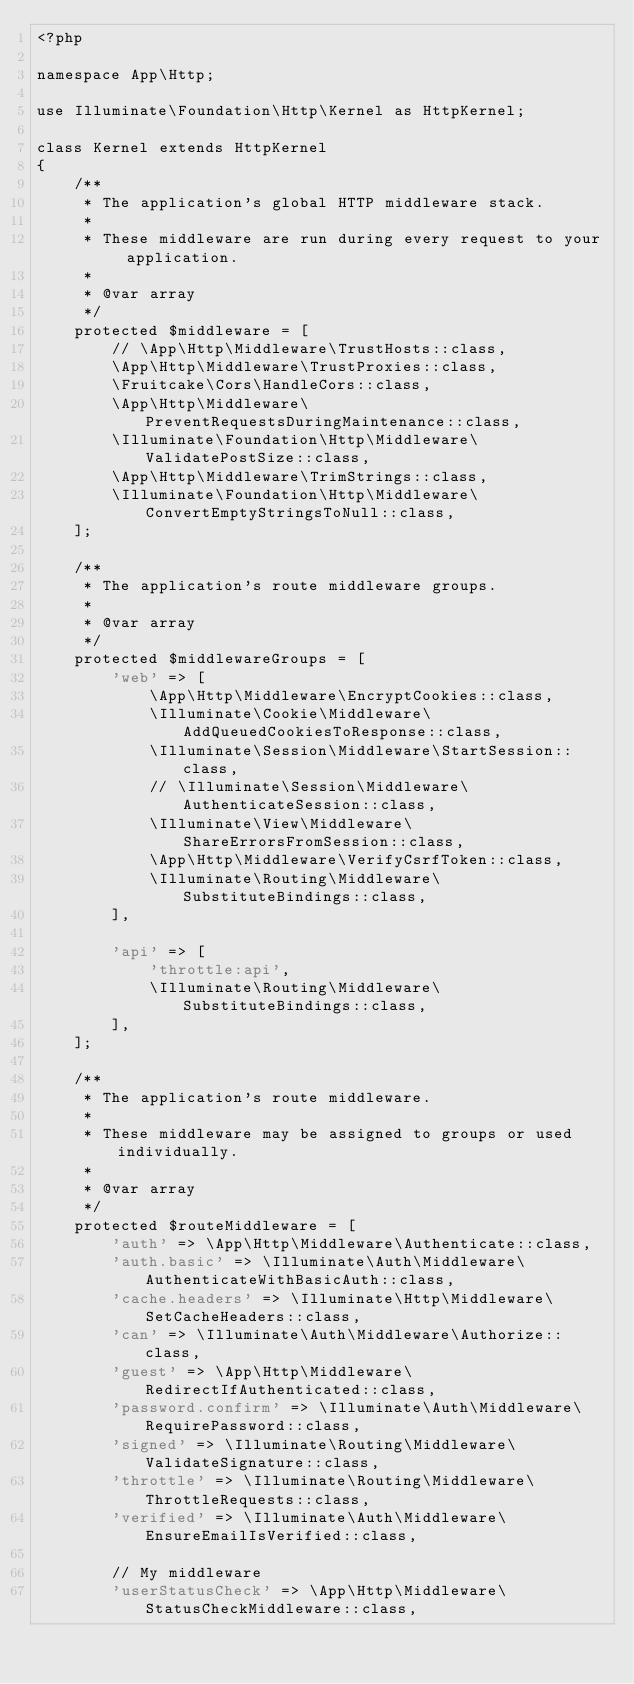Convert code to text. <code><loc_0><loc_0><loc_500><loc_500><_PHP_><?php

namespace App\Http;

use Illuminate\Foundation\Http\Kernel as HttpKernel;

class Kernel extends HttpKernel
{
    /**
     * The application's global HTTP middleware stack.
     *
     * These middleware are run during every request to your application.
     *
     * @var array
     */
    protected $middleware = [
        // \App\Http\Middleware\TrustHosts::class,
        \App\Http\Middleware\TrustProxies::class,
        \Fruitcake\Cors\HandleCors::class,
        \App\Http\Middleware\PreventRequestsDuringMaintenance::class,
        \Illuminate\Foundation\Http\Middleware\ValidatePostSize::class,
        \App\Http\Middleware\TrimStrings::class,
        \Illuminate\Foundation\Http\Middleware\ConvertEmptyStringsToNull::class,
    ];

    /**
     * The application's route middleware groups.
     *
     * @var array
     */
    protected $middlewareGroups = [
        'web' => [
            \App\Http\Middleware\EncryptCookies::class,
            \Illuminate\Cookie\Middleware\AddQueuedCookiesToResponse::class,
            \Illuminate\Session\Middleware\StartSession::class,
            // \Illuminate\Session\Middleware\AuthenticateSession::class,
            \Illuminate\View\Middleware\ShareErrorsFromSession::class,
            \App\Http\Middleware\VerifyCsrfToken::class,
            \Illuminate\Routing\Middleware\SubstituteBindings::class,
        ],

        'api' => [
            'throttle:api',
            \Illuminate\Routing\Middleware\SubstituteBindings::class,
        ],
    ];

    /**
     * The application's route middleware.
     *
     * These middleware may be assigned to groups or used individually.
     *
     * @var array
     */
    protected $routeMiddleware = [
        'auth' => \App\Http\Middleware\Authenticate::class,
        'auth.basic' => \Illuminate\Auth\Middleware\AuthenticateWithBasicAuth::class,
        'cache.headers' => \Illuminate\Http\Middleware\SetCacheHeaders::class,
        'can' => \Illuminate\Auth\Middleware\Authorize::class,
        'guest' => \App\Http\Middleware\RedirectIfAuthenticated::class,
        'password.confirm' => \Illuminate\Auth\Middleware\RequirePassword::class,
        'signed' => \Illuminate\Routing\Middleware\ValidateSignature::class,
        'throttle' => \Illuminate\Routing\Middleware\ThrottleRequests::class,
        'verified' => \Illuminate\Auth\Middleware\EnsureEmailIsVerified::class,

        // My middleware
        'userStatusCheck' => \App\Http\Middleware\StatusCheckMiddleware::class,</code> 